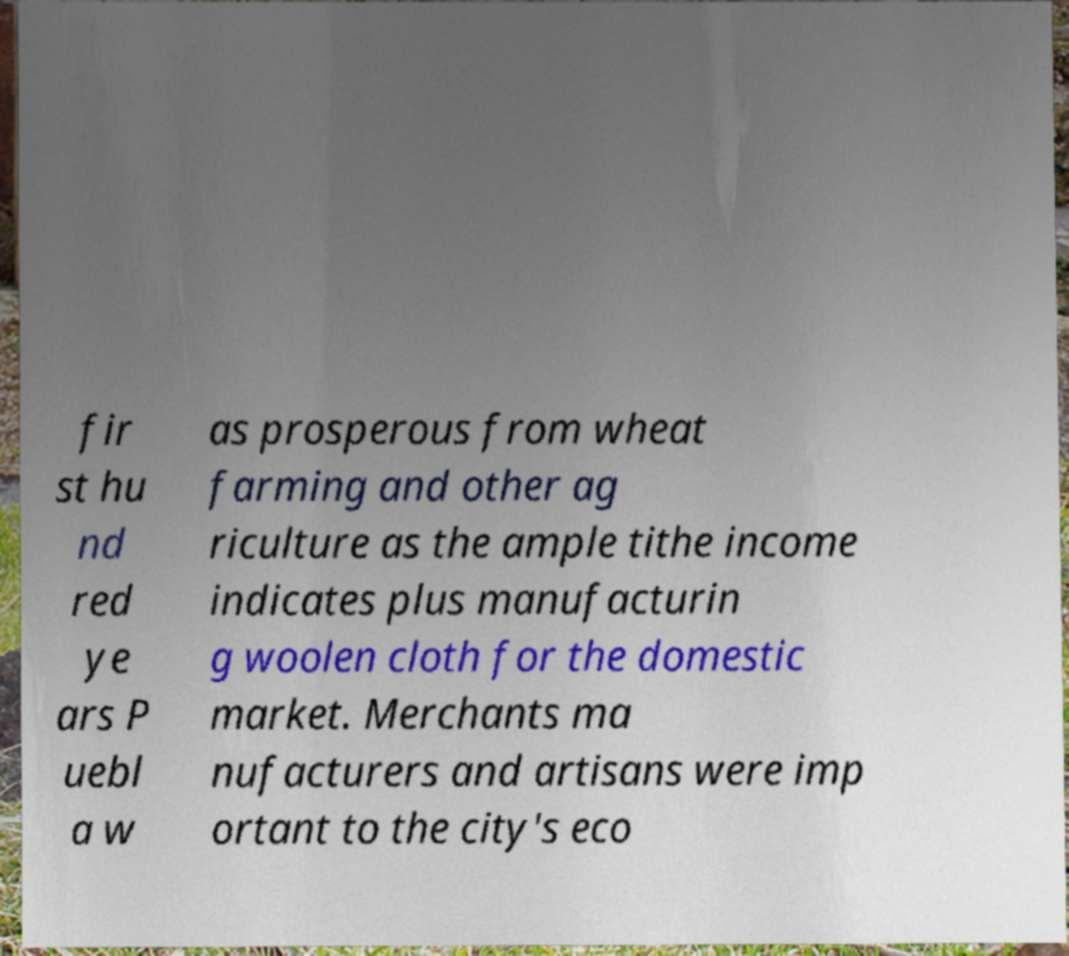There's text embedded in this image that I need extracted. Can you transcribe it verbatim? fir st hu nd red ye ars P uebl a w as prosperous from wheat farming and other ag riculture as the ample tithe income indicates plus manufacturin g woolen cloth for the domestic market. Merchants ma nufacturers and artisans were imp ortant to the city's eco 